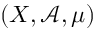<formula> <loc_0><loc_0><loc_500><loc_500>( X , { \mathcal { A } } , \mu )</formula> 